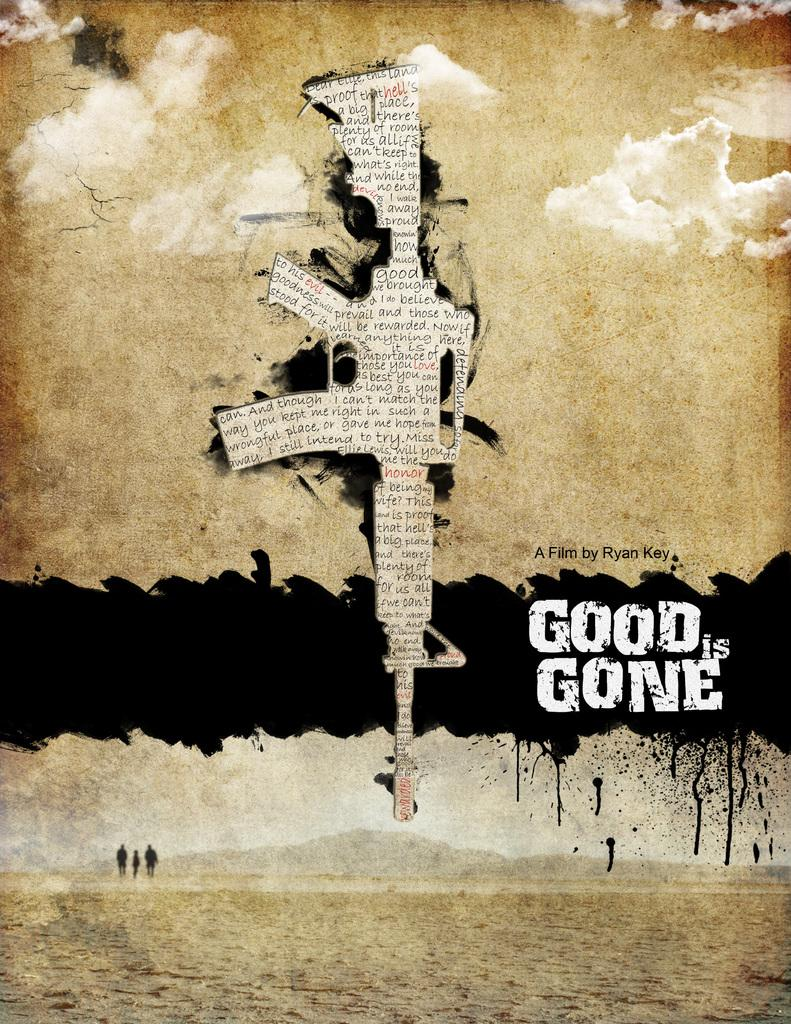<image>
Provide a brief description of the given image. A movie poster for Good is Gone features a rifle made of newsprint with the muzzle facing the ground. 